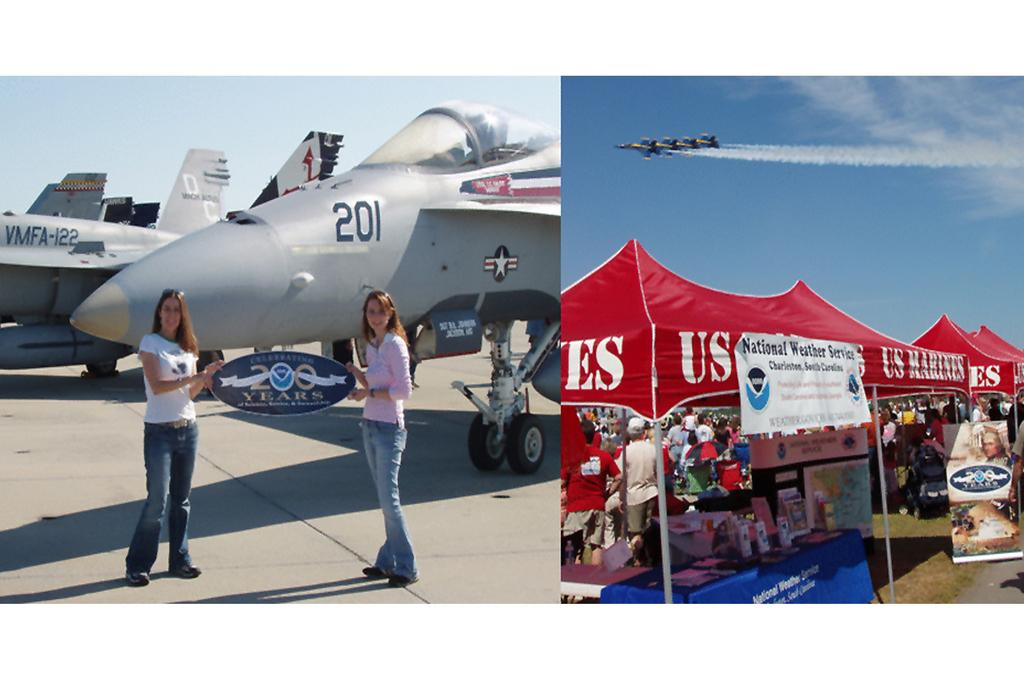<image>
Provide a brief description of the given image. Two girls holding a sign that commemorates 200 years 